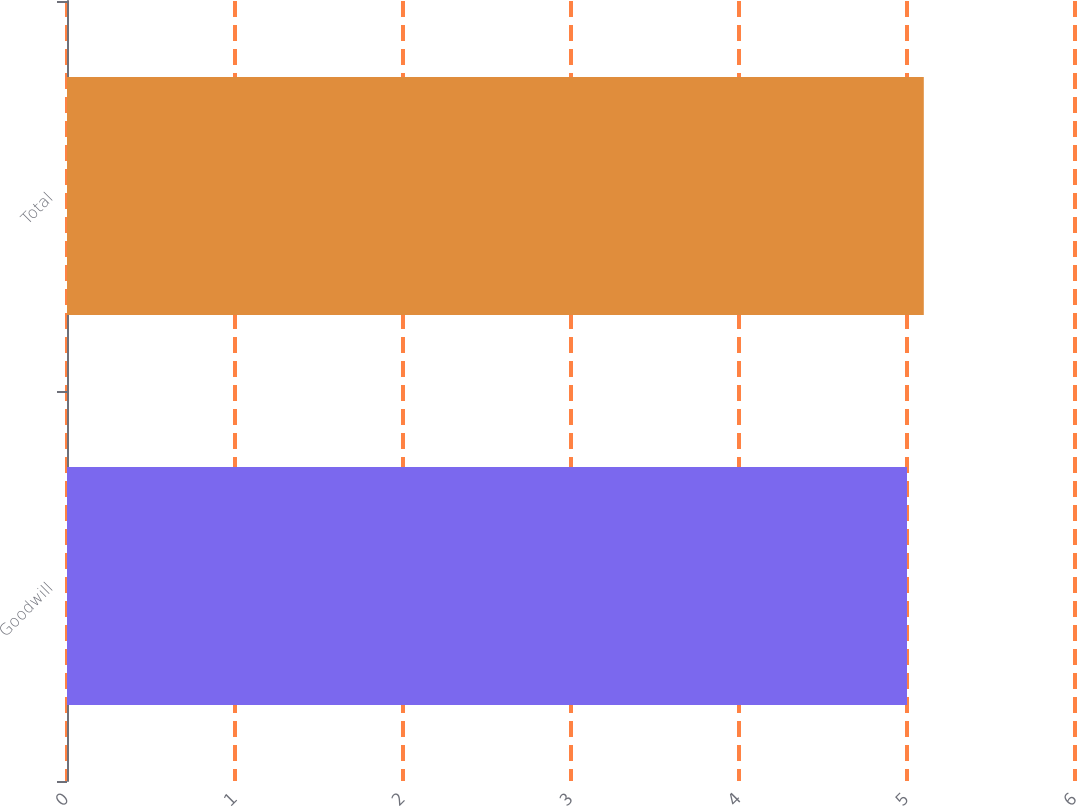Convert chart. <chart><loc_0><loc_0><loc_500><loc_500><bar_chart><fcel>Goodwill<fcel>Total<nl><fcel>5<fcel>5.1<nl></chart> 